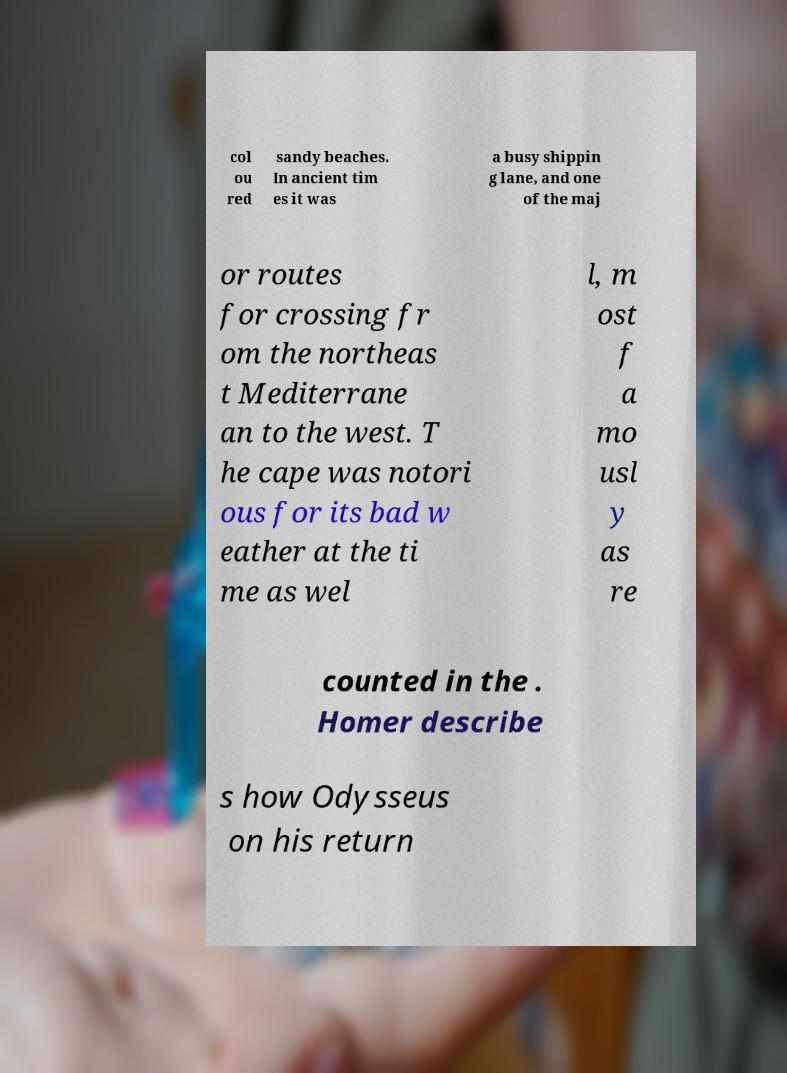What messages or text are displayed in this image? I need them in a readable, typed format. col ou red sandy beaches. In ancient tim es it was a busy shippin g lane, and one of the maj or routes for crossing fr om the northeas t Mediterrane an to the west. T he cape was notori ous for its bad w eather at the ti me as wel l, m ost f a mo usl y as re counted in the . Homer describe s how Odysseus on his return 